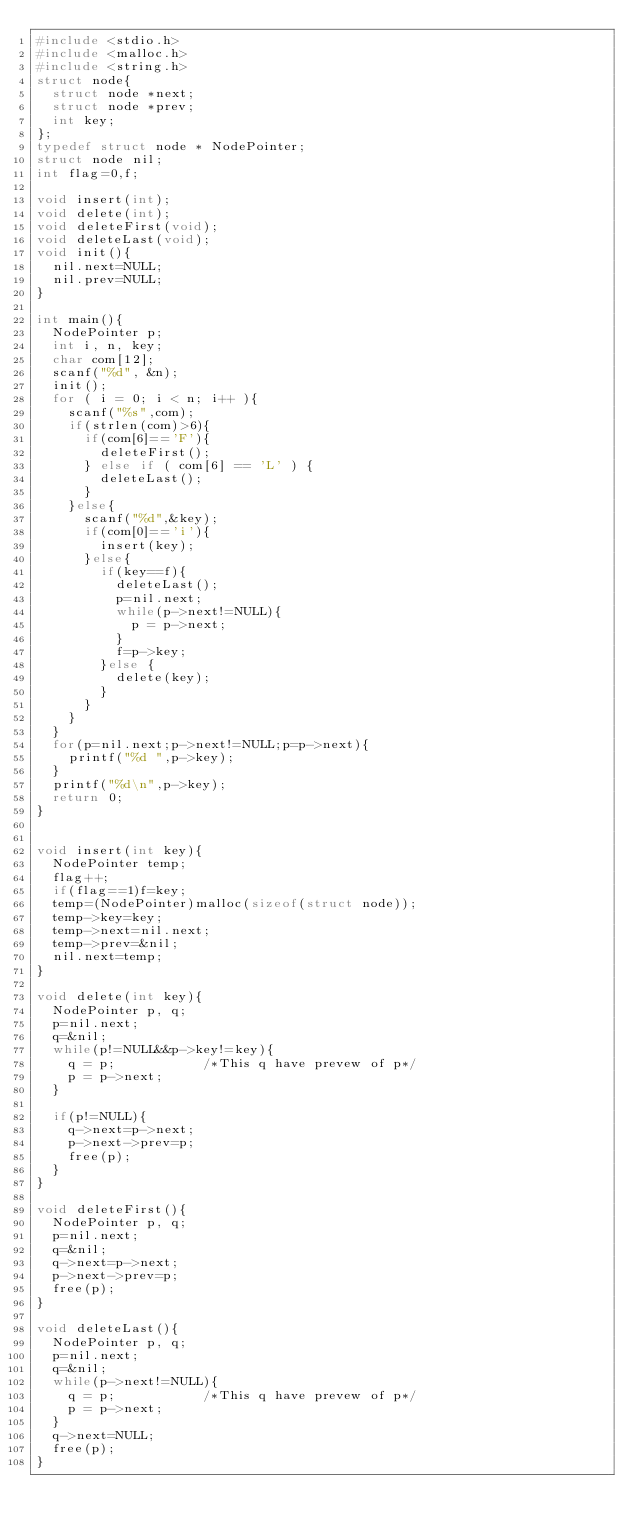Convert code to text. <code><loc_0><loc_0><loc_500><loc_500><_C_>#include <stdio.h>
#include <malloc.h>
#include <string.h>
struct node{
  struct node *next;
  struct node *prev;
  int key;
};
typedef struct node * NodePointer;
struct node nil;
int flag=0,f;

void insert(int);
void delete(int);
void deleteFirst(void);
void deleteLast(void);
void init(){
	nil.next=NULL;
	nil.prev=NULL;
}

int main(){
	NodePointer p;
	int i, n, key;
	char com[12];
	scanf("%d", &n);
	init();
	for ( i = 0; i < n; i++ ){
		scanf("%s",com);
		if(strlen(com)>6){
			if(com[6]=='F'){
				deleteFirst();
			} else if ( com[6] == 'L' ) {
				deleteLast();
			} 
		}else{
			scanf("%d",&key);
			if(com[0]=='i'){
				insert(key);
			}else{
				if(key==f){
      		deleteLast();
      		p=nil.next;
      		while(p->next!=NULL){
    				p = p->next;
					}
					f=p->key;
      	}else {
      		delete(key);
        }
      }
  	}
	}
  for(p=nil.next;p->next!=NULL;p=p->next){
    printf("%d ",p->key);
  }
  printf("%d\n",p->key);
  return 0;
}


void insert(int key){
	NodePointer temp;
	flag++;
	if(flag==1)f=key;
	temp=(NodePointer)malloc(sizeof(struct node));
	temp->key=key;
	temp->next=nil.next;
	temp->prev=&nil;
	nil.next=temp;
}

void delete(int key){
	NodePointer p, q;
	p=nil.next;
	q=&nil;
	while(p!=NULL&&p->key!=key){
		q = p;           /*This q have prevew of p*/
    p = p->next;
	}
	
	if(p!=NULL){
 		q->next=p->next;
		p->next->prev=p;
		free(p);
	}
}

void deleteFirst(){
	NodePointer p, q;
	p=nil.next;
	q=&nil;
	q->next=p->next;
	p->next->prev=p;
	free(p);
}

void deleteLast(){
	NodePointer p, q;
	p=nil.next;
	q=&nil;
	while(p->next!=NULL){
		q = p;           /*This q have prevew of p*/
    p = p->next;
	}
	q->next=NULL;
	free(p);
}</code> 